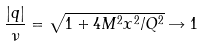<formula> <loc_0><loc_0><loc_500><loc_500>\frac { \left | { q } \right | } { \nu } = \sqrt { 1 + 4 M ^ { 2 } x ^ { 2 } / Q ^ { 2 } } \rightarrow 1</formula> 